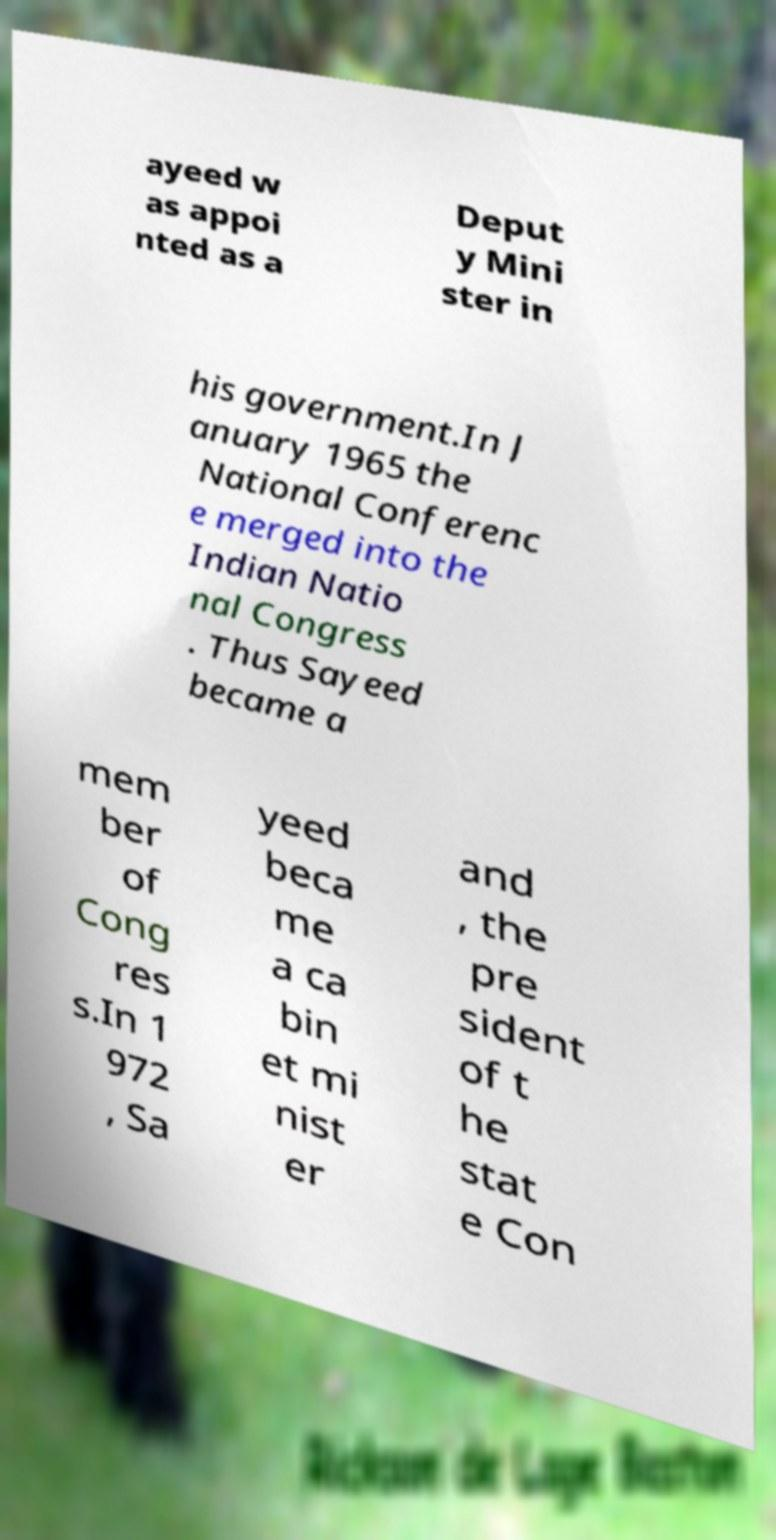Please read and relay the text visible in this image. What does it say? ayeed w as appoi nted as a Deput y Mini ster in his government.In J anuary 1965 the National Conferenc e merged into the Indian Natio nal Congress . Thus Sayeed became a mem ber of Cong res s.In 1 972 , Sa yeed beca me a ca bin et mi nist er and , the pre sident of t he stat e Con 